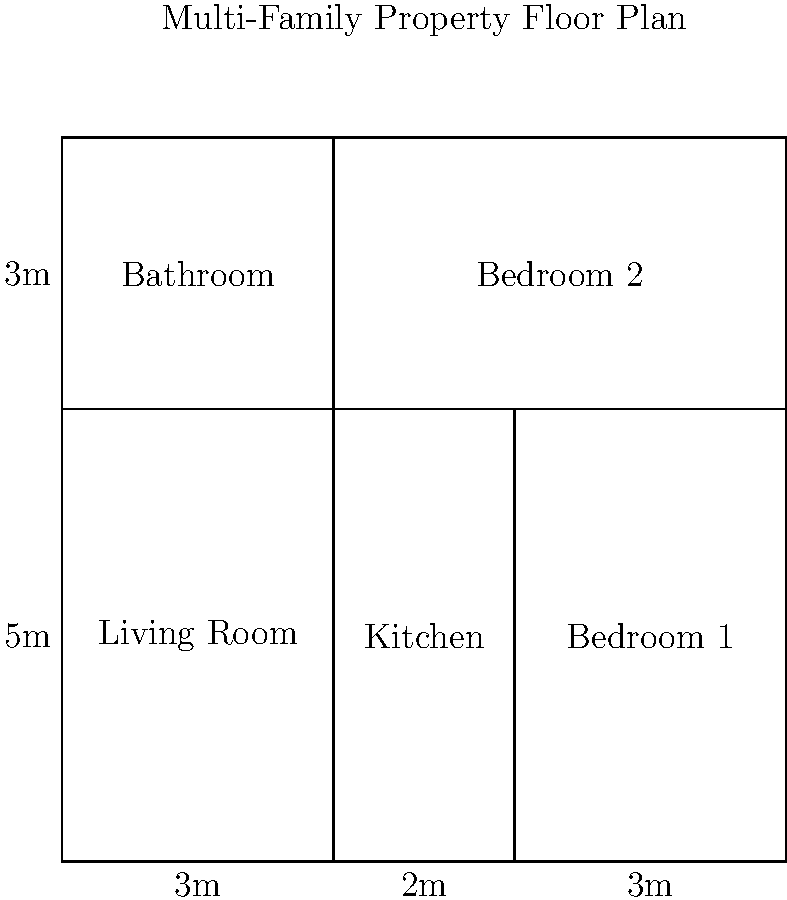Based on the provided floor plan of a multi-family property unit, calculate the total rentable square footage. Assume that all interior walls are 6 inches (0.5 feet) thick, and the exterior walls are 1 foot thick. Round your answer to the nearest whole number. To calculate the total rentable square footage, we need to follow these steps:

1. Calculate the exterior dimensions:
   Width: $3m + 2m + 3m = 8m$ (26.25 feet)
   Length: $5m + 3m = 8m$ (26.25 feet)

2. Convert meters to feet:
   $8m \times 3.28084 = 26.25$ feet (both width and length)

3. Calculate the gross square footage:
   $26.25 \text{ ft} \times 26.25 \text{ ft} = 689.06$ sq ft

4. Account for exterior walls:
   Subtract 1 foot from each dimension:
   $(26.25 - 2) \times (26.25 - 2) = 24.25 \times 24.25 = 588.06$ sq ft

5. Account for interior walls:
   There are two full-length interior walls (one horizontal, one vertical):
   Horizontal wall: $24.25 \times 0.5 = 12.125$ sq ft
   Vertical wall: $24.25 \times 0.5 = 12.125$ sq ft
   Total interior wall area: $12.125 + 12.125 = 24.25$ sq ft

6. Calculate the rentable square footage:
   $588.06 - 24.25 = 563.81$ sq ft

7. Round to the nearest whole number:
   $564$ sq ft
Answer: 564 sq ft 